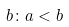<formula> <loc_0><loc_0><loc_500><loc_500>b \colon a < b</formula> 